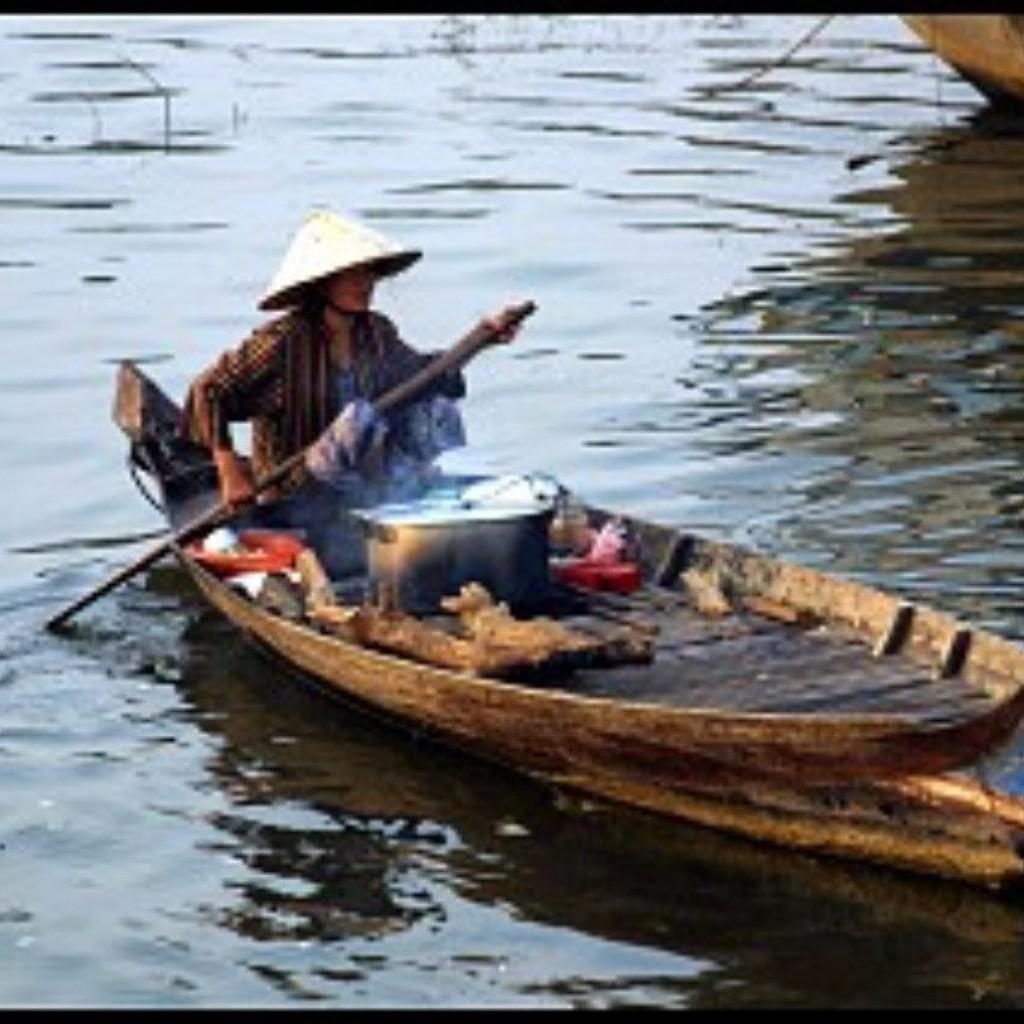Please provide a concise description of this image. This is completely an outdoor picture. This is a river and here we can see a partial part of the boat is visible. Here we can see a boat and in which one man is sitting and riding a boat with a pedal in his hands. This is the vessel. This man wore a hat over his head. 